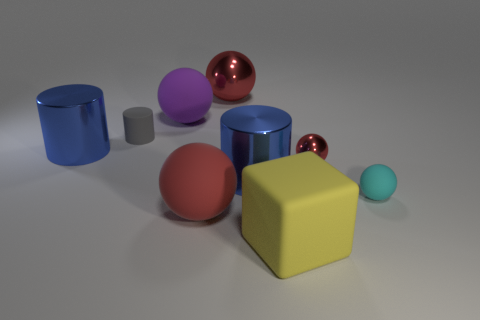How many tiny objects are red objects or gray things?
Make the answer very short. 2. What number of blue cylinders are behind the tiny cyan matte thing?
Your answer should be very brief. 2. Is the number of large blue metal objects that are left of the purple rubber object greater than the number of small red spheres?
Provide a succinct answer. No. What is the shape of the purple object that is made of the same material as the small cyan thing?
Give a very brief answer. Sphere. The large metallic object behind the shiny object on the left side of the large red rubber object is what color?
Your answer should be compact. Red. Does the large red metal thing have the same shape as the tiny red metallic thing?
Ensure brevity in your answer.  Yes. What is the material of the small red thing that is the same shape as the large purple matte object?
Your answer should be compact. Metal. There is a gray thing in front of the big shiny thing that is behind the tiny gray thing; are there any tiny rubber spheres to the left of it?
Make the answer very short. No. Is the shape of the big red metallic thing the same as the red metal thing right of the big yellow block?
Your answer should be very brief. Yes. Are there any other things that are the same color as the rubber cylinder?
Offer a very short reply. No. 